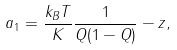<formula> <loc_0><loc_0><loc_500><loc_500>a _ { 1 } = \frac { k _ { B } T } { K } \frac { 1 } { Q ( 1 - Q ) } - z ,</formula> 